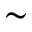<formula> <loc_0><loc_0><loc_500><loc_500>\sim</formula> 